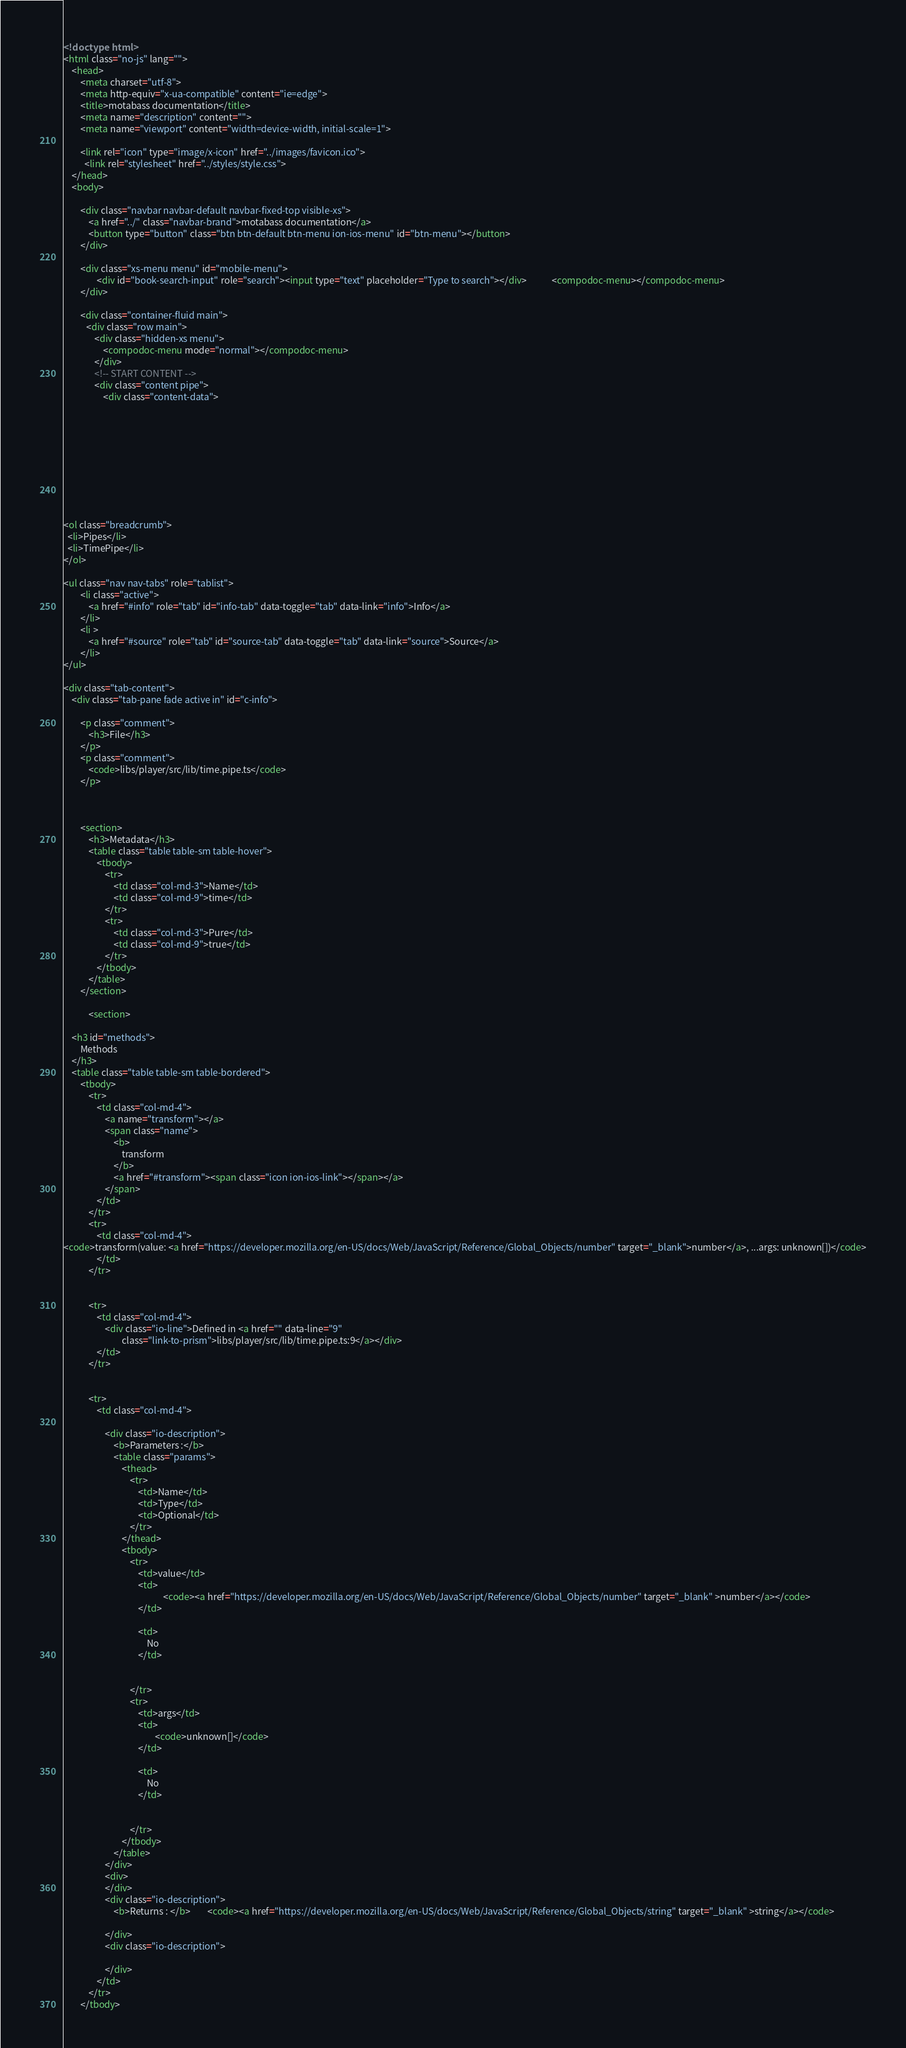<code> <loc_0><loc_0><loc_500><loc_500><_HTML_><!doctype html>
<html class="no-js" lang="">
    <head>
        <meta charset="utf-8">
        <meta http-equiv="x-ua-compatible" content="ie=edge">
        <title>motabass documentation</title>
        <meta name="description" content="">
        <meta name="viewport" content="width=device-width, initial-scale=1">

        <link rel="icon" type="image/x-icon" href="../images/favicon.ico">
	      <link rel="stylesheet" href="../styles/style.css">
    </head>
    <body>

        <div class="navbar navbar-default navbar-fixed-top visible-xs">
            <a href="../" class="navbar-brand">motabass documentation</a>
            <button type="button" class="btn btn-default btn-menu ion-ios-menu" id="btn-menu"></button>
        </div>

        <div class="xs-menu menu" id="mobile-menu">
                <div id="book-search-input" role="search"><input type="text" placeholder="Type to search"></div>            <compodoc-menu></compodoc-menu>
        </div>

        <div class="container-fluid main">
           <div class="row main">
               <div class="hidden-xs menu">
                   <compodoc-menu mode="normal"></compodoc-menu>
               </div>
               <!-- START CONTENT -->
               <div class="content pipe">
                   <div class="content-data">










<ol class="breadcrumb">
  <li>Pipes</li>
  <li>TimePipe</li>
</ol>

<ul class="nav nav-tabs" role="tablist">
        <li class="active">
            <a href="#info" role="tab" id="info-tab" data-toggle="tab" data-link="info">Info</a>
        </li>
        <li >
            <a href="#source" role="tab" id="source-tab" data-toggle="tab" data-link="source">Source</a>
        </li>
</ul>

<div class="tab-content">
    <div class="tab-pane fade active in" id="c-info">

        <p class="comment">
            <h3>File</h3>
        </p>
        <p class="comment">
            <code>libs/player/src/lib/time.pipe.ts</code>
        </p>



        <section>
            <h3>Metadata</h3>
            <table class="table table-sm table-hover">
                <tbody>
                    <tr>
                        <td class="col-md-3">Name</td>
                        <td class="col-md-9">time</td>
                    </tr>
                    <tr>
                        <td class="col-md-3">Pure</td>
                        <td class="col-md-9">true</td>
                    </tr>
                </tbody>
            </table>
        </section>

            <section>
    
    <h3 id="methods">
        Methods
    </h3>
    <table class="table table-sm table-bordered">
        <tbody>
            <tr>
                <td class="col-md-4">
                    <a name="transform"></a>
                    <span class="name">
                        <b>
                            transform
                        </b>
                        <a href="#transform"><span class="icon ion-ios-link"></span></a>
                    </span>
                </td>
            </tr>
            <tr>
                <td class="col-md-4">
<code>transform(value: <a href="https://developer.mozilla.org/en-US/docs/Web/JavaScript/Reference/Global_Objects/number" target="_blank">number</a>, ...args: unknown[])</code>
                </td>
            </tr>


            <tr>
                <td class="col-md-4">
                    <div class="io-line">Defined in <a href="" data-line="9"
                            class="link-to-prism">libs/player/src/lib/time.pipe.ts:9</a></div>
                </td>
            </tr>


            <tr>
                <td class="col-md-4">

                    <div class="io-description">
                        <b>Parameters :</b>
                        <table class="params">
                            <thead>
                                <tr>
                                    <td>Name</td>
                                    <td>Type</td>
                                    <td>Optional</td>
                                </tr>
                            </thead>
                            <tbody>
                                <tr>
                                    <td>value</td>
                                    <td>
                                                <code><a href="https://developer.mozilla.org/en-US/docs/Web/JavaScript/Reference/Global_Objects/number" target="_blank" >number</a></code>
                                    </td>

                                    <td>
                                        No
                                    </td>


                                </tr>
                                <tr>
                                    <td>args</td>
                                    <td>
                                            <code>unknown[]</code>
                                    </td>

                                    <td>
                                        No
                                    </td>


                                </tr>
                            </tbody>
                        </table>
                    </div>
                    <div>
                    </div>
                    <div class="io-description">
                        <b>Returns : </b>        <code><a href="https://developer.mozilla.org/en-US/docs/Web/JavaScript/Reference/Global_Objects/string" target="_blank" >string</a></code>

                    </div>
                    <div class="io-description">
                        
                    </div>
                </td>
            </tr>
        </tbody></code> 